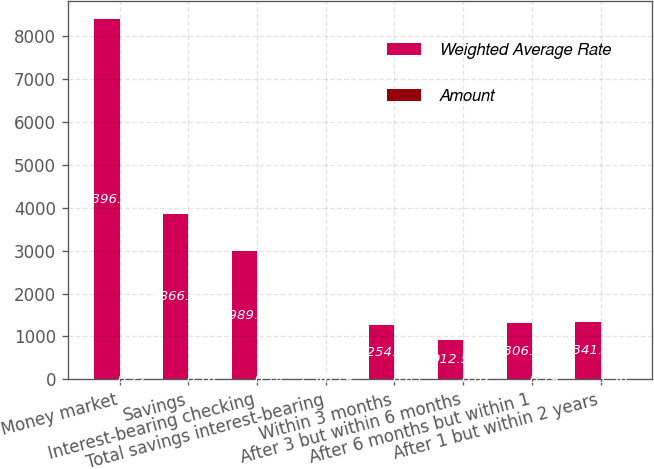Convert chart to OTSL. <chart><loc_0><loc_0><loc_500><loc_500><stacked_bar_chart><ecel><fcel>Money market<fcel>Savings<fcel>Interest-bearing checking<fcel>Total savings interest-bearing<fcel>Within 3 months<fcel>After 3 but within 6 months<fcel>After 6 months but within 1<fcel>After 1 but within 2 years<nl><fcel>Weighted Average Rate<fcel>8396.2<fcel>3866.8<fcel>2989.4<fcel>1.36<fcel>1254.3<fcel>912.5<fcel>1306.7<fcel>1341<nl><fcel>Amount<fcel>0.22<fcel>0.16<fcel>0.14<fcel>0.19<fcel>0.63<fcel>0.62<fcel>0.79<fcel>1.36<nl></chart> 